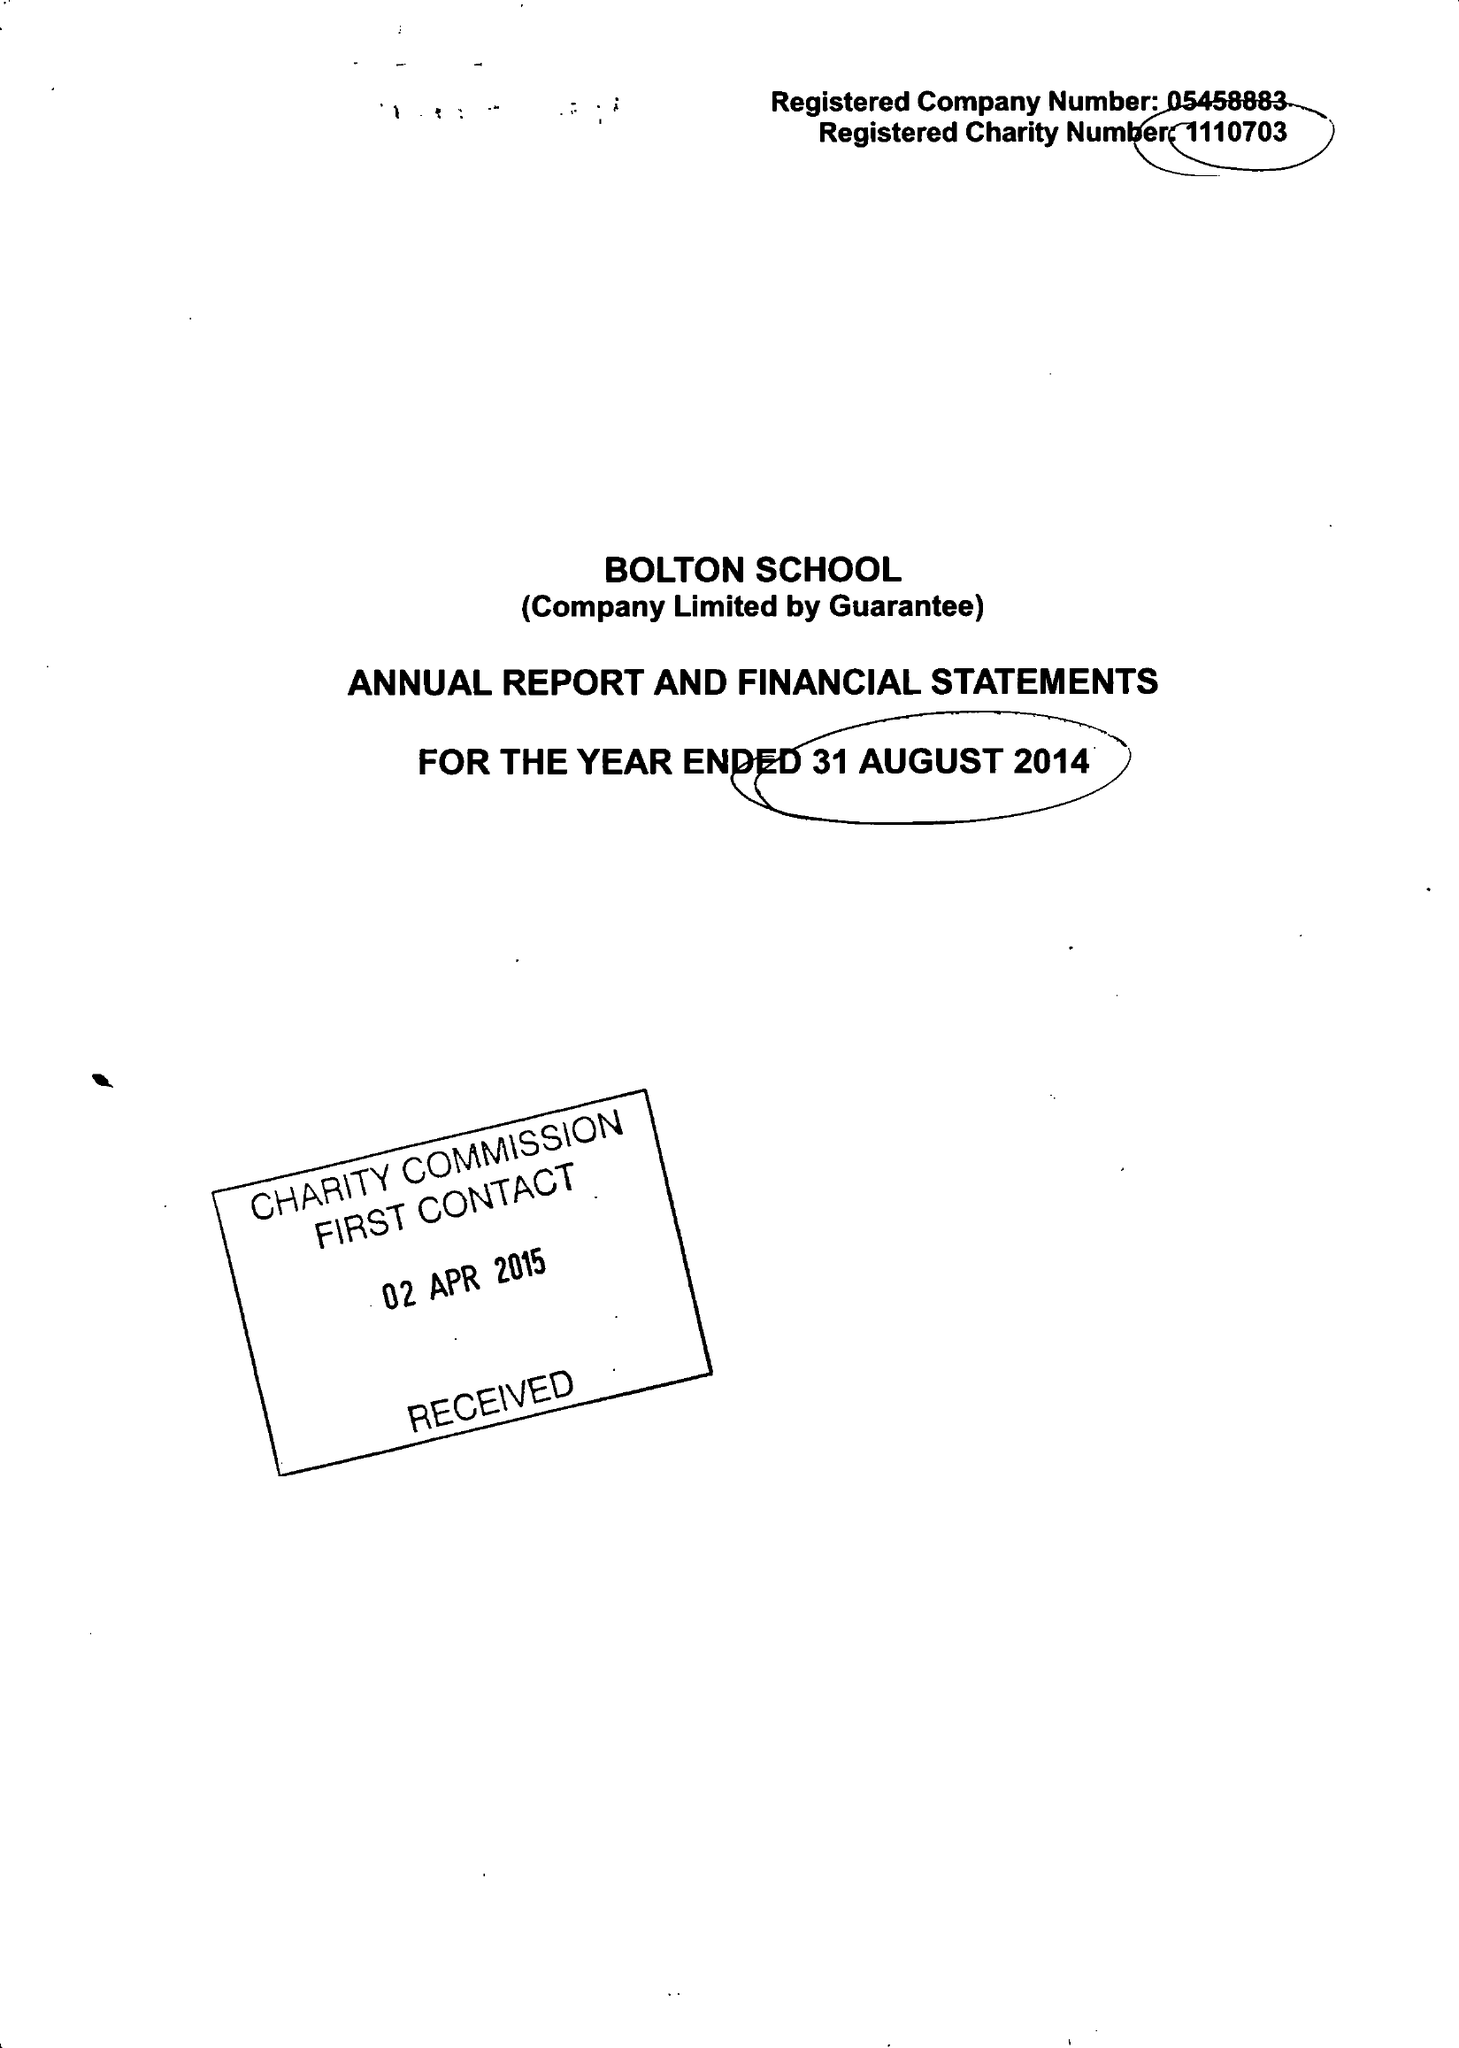What is the value for the address__post_town?
Answer the question using a single word or phrase. BOLTON 